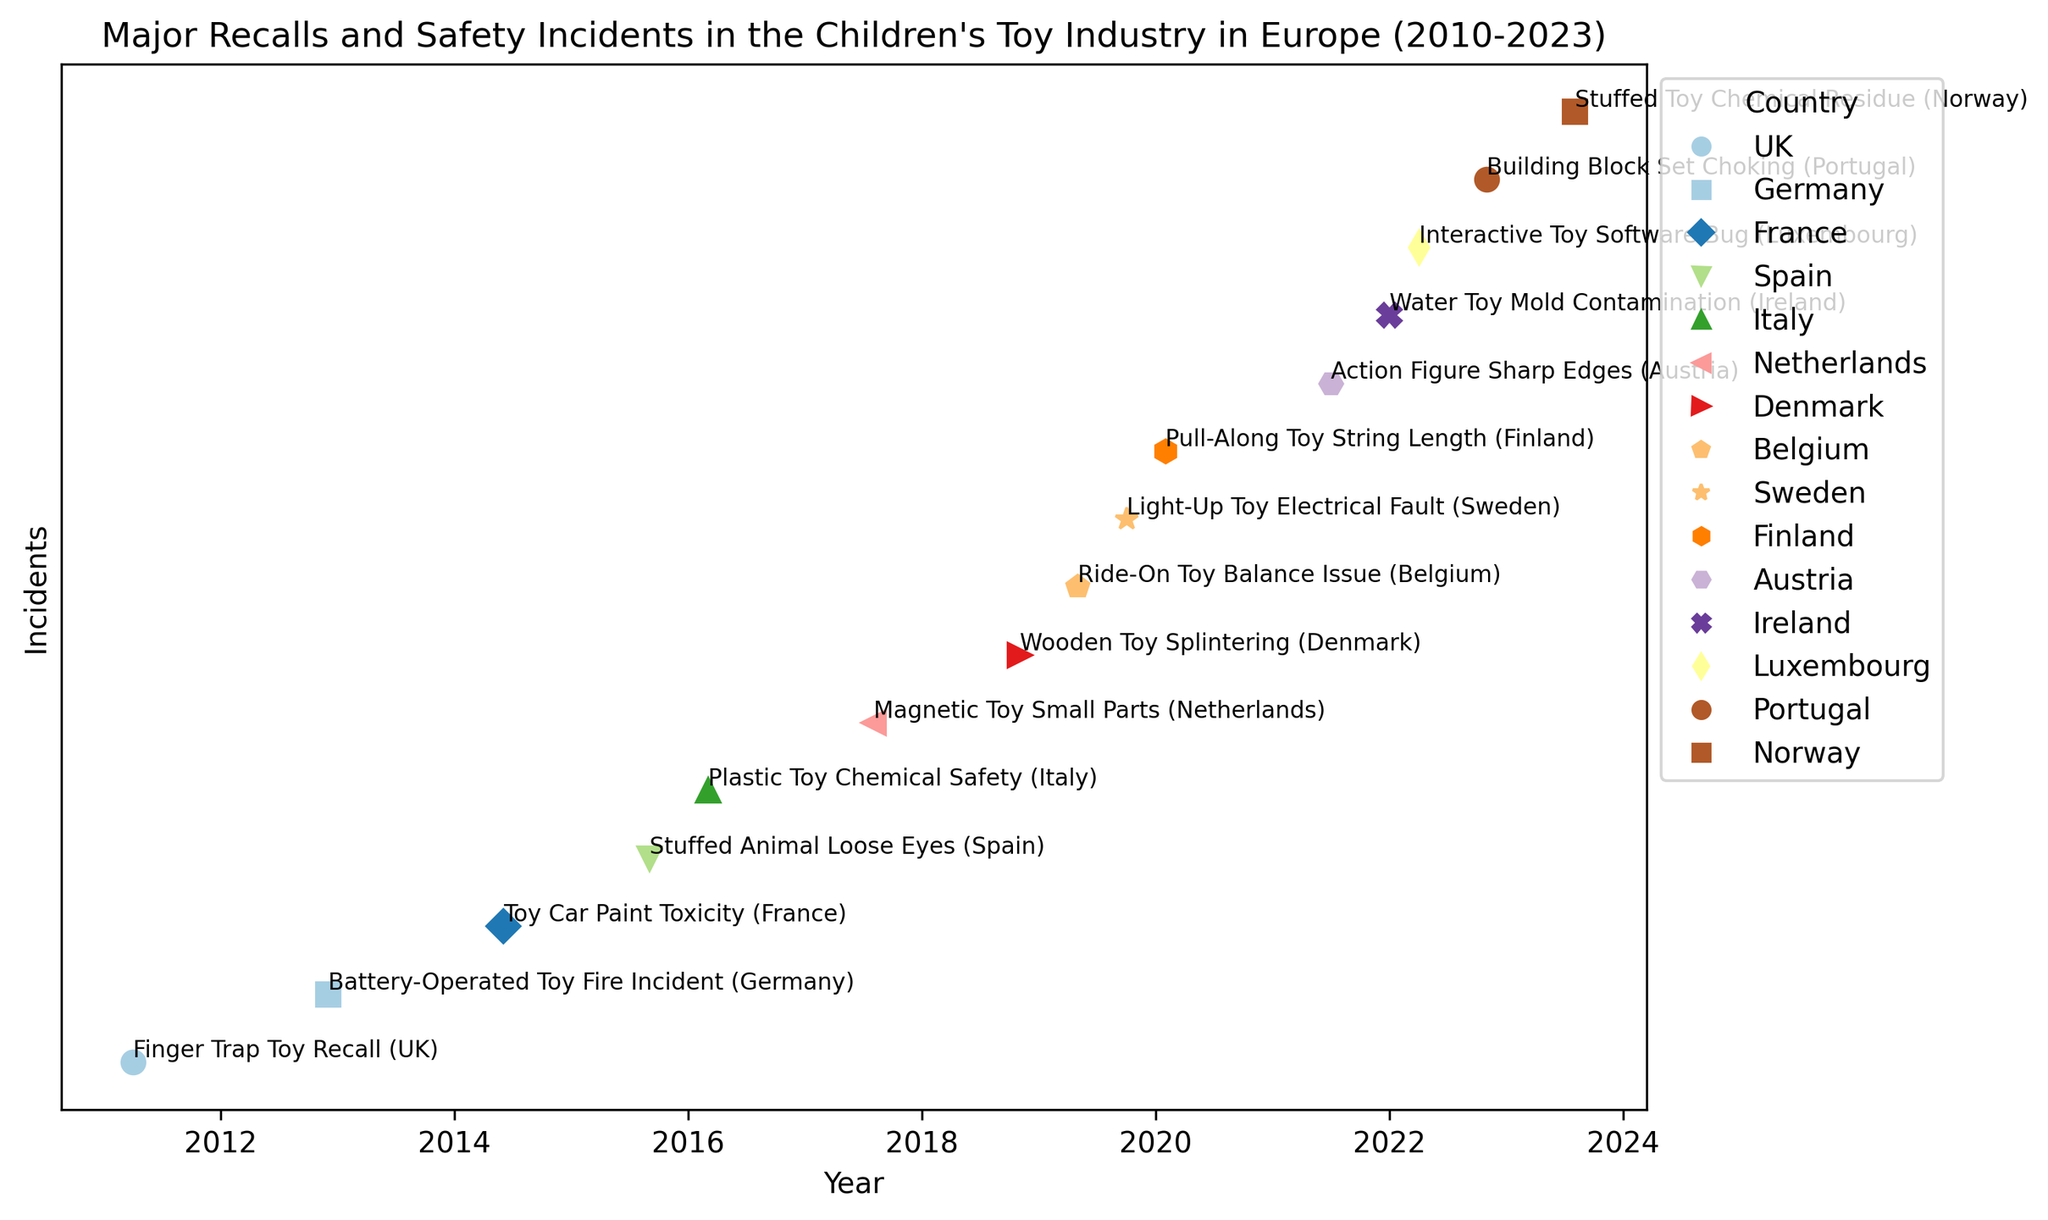Which country had the first recorded safety incident since 2010? Look for the earliest date in the plot and identify the country associated with it. The earliest incident occurred in March 2011. Therefore, the country is the UK since the "Finger Trap Toy Recall" incident happened in the UK in March 2011.
Answer: UK Which country had the most incidents between 2010 and 2023? Count the number of incidents for each country listed in the plot between 2010 and 2023. Germany has only one incident in 2012, while other countries also have one. Therefore, there isn't a country that has the most incidents based on the given data; each listed country has one incident.
Answer: Multiple countries (each has one incident) What safety hazard was most frequently cited in the incidents? Examine the plot for recurring safety issues in the "Details" section of the incidents. The hazards include choking, fire, toxicity, small parts, chemicals, etc. Choking hazards appear three times (UK in 2011, Spain in 2015, Portugal in 2022).
Answer: Choking hazard How many incidents involved chemical safety concerns? Count the number of data points related to chemical safety issues in the plot. These include incidents involving toxicity, phthalates, and chemical residues. There are three such incidents (France in 2014, Italy in 2016, Norway in 2023).
Answer: Three In which month(s) did the highest number of incidents occur? Analyze the plot to determine which month has the most incidents by comparing the incidents each month. The month with the highest number of occurrences is March, with two incidents (2011 and 2022).
Answer: March How many safety incidents occurred after 2019? Look at the incidents from 2020 onwards in the plot and count the number of these incidents. There are six such incidents (2020, 2021 (2 incidents), 2022 (2 incidents), 2023).
Answer: Six Which country had an incident involving software issues? Find mentions of "software" in the incident description in the plot. The "Interactive Toy Software Bug" incident in March 2022 affected Luxembourg.
Answer: Luxembourg Compare the diversity of incident types between 2017 and 2022. How many unique incident types were there in this period? Identify the types of incidents by examining their details from 2017 to 2022 and count the unique types. The types include swallowing risk, splintering, balance issue, electrical fault, strangulation hazard, sharp edges, mold contamination, software bug, choking, and chemical residue. There are ten unique incident types during this period.
Answer: Ten 